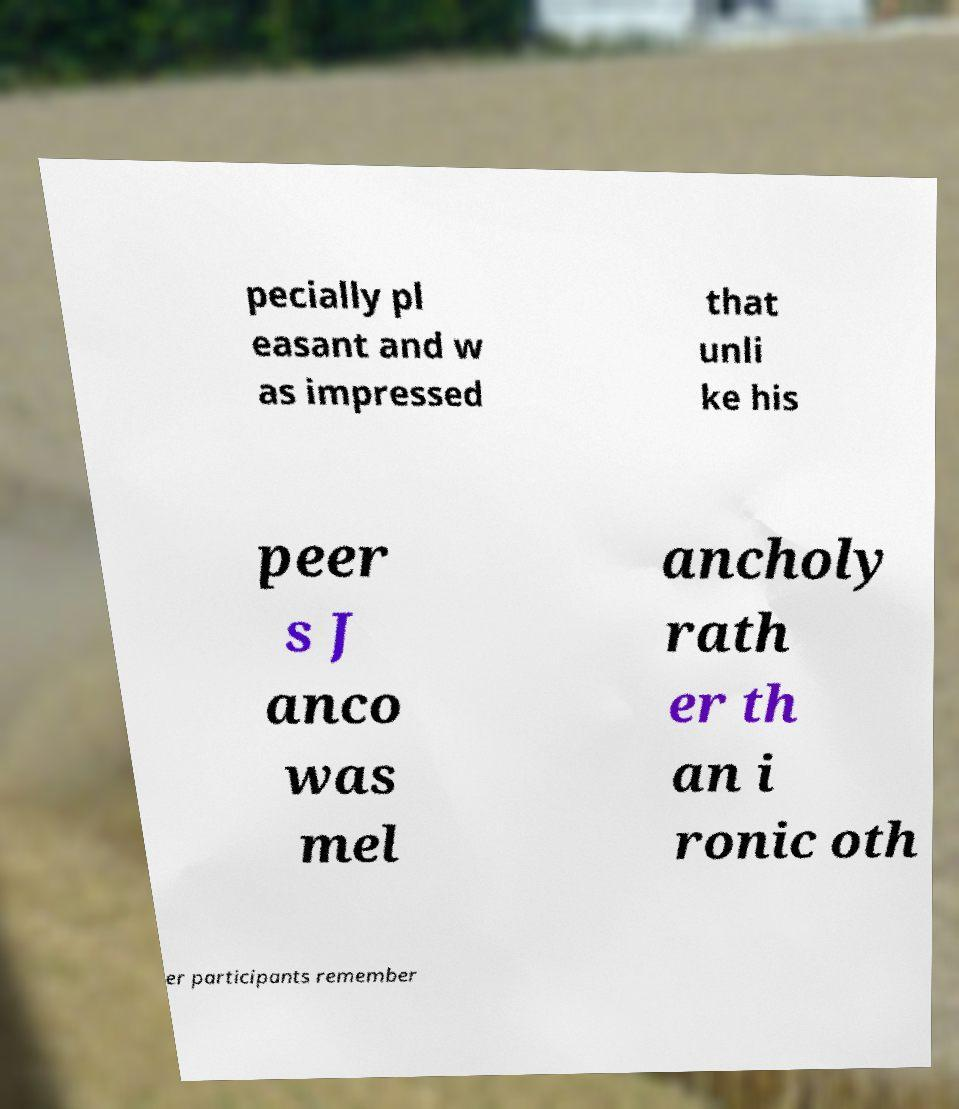Please identify and transcribe the text found in this image. pecially pl easant and w as impressed that unli ke his peer s J anco was mel ancholy rath er th an i ronic oth er participants remember 